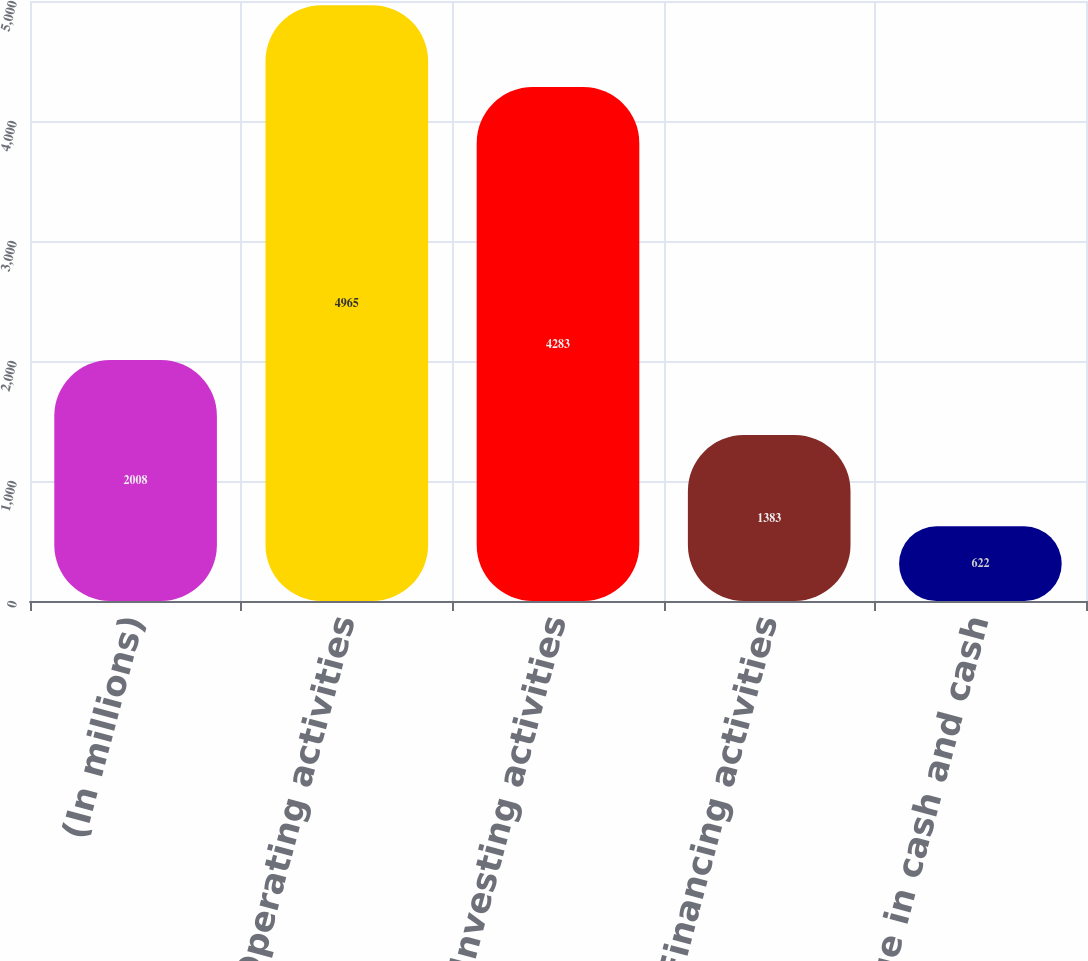<chart> <loc_0><loc_0><loc_500><loc_500><bar_chart><fcel>(In millions)<fcel>Operating activities<fcel>Investing activities<fcel>Financing activities<fcel>Net change in cash and cash<nl><fcel>2008<fcel>4965<fcel>4283<fcel>1383<fcel>622<nl></chart> 